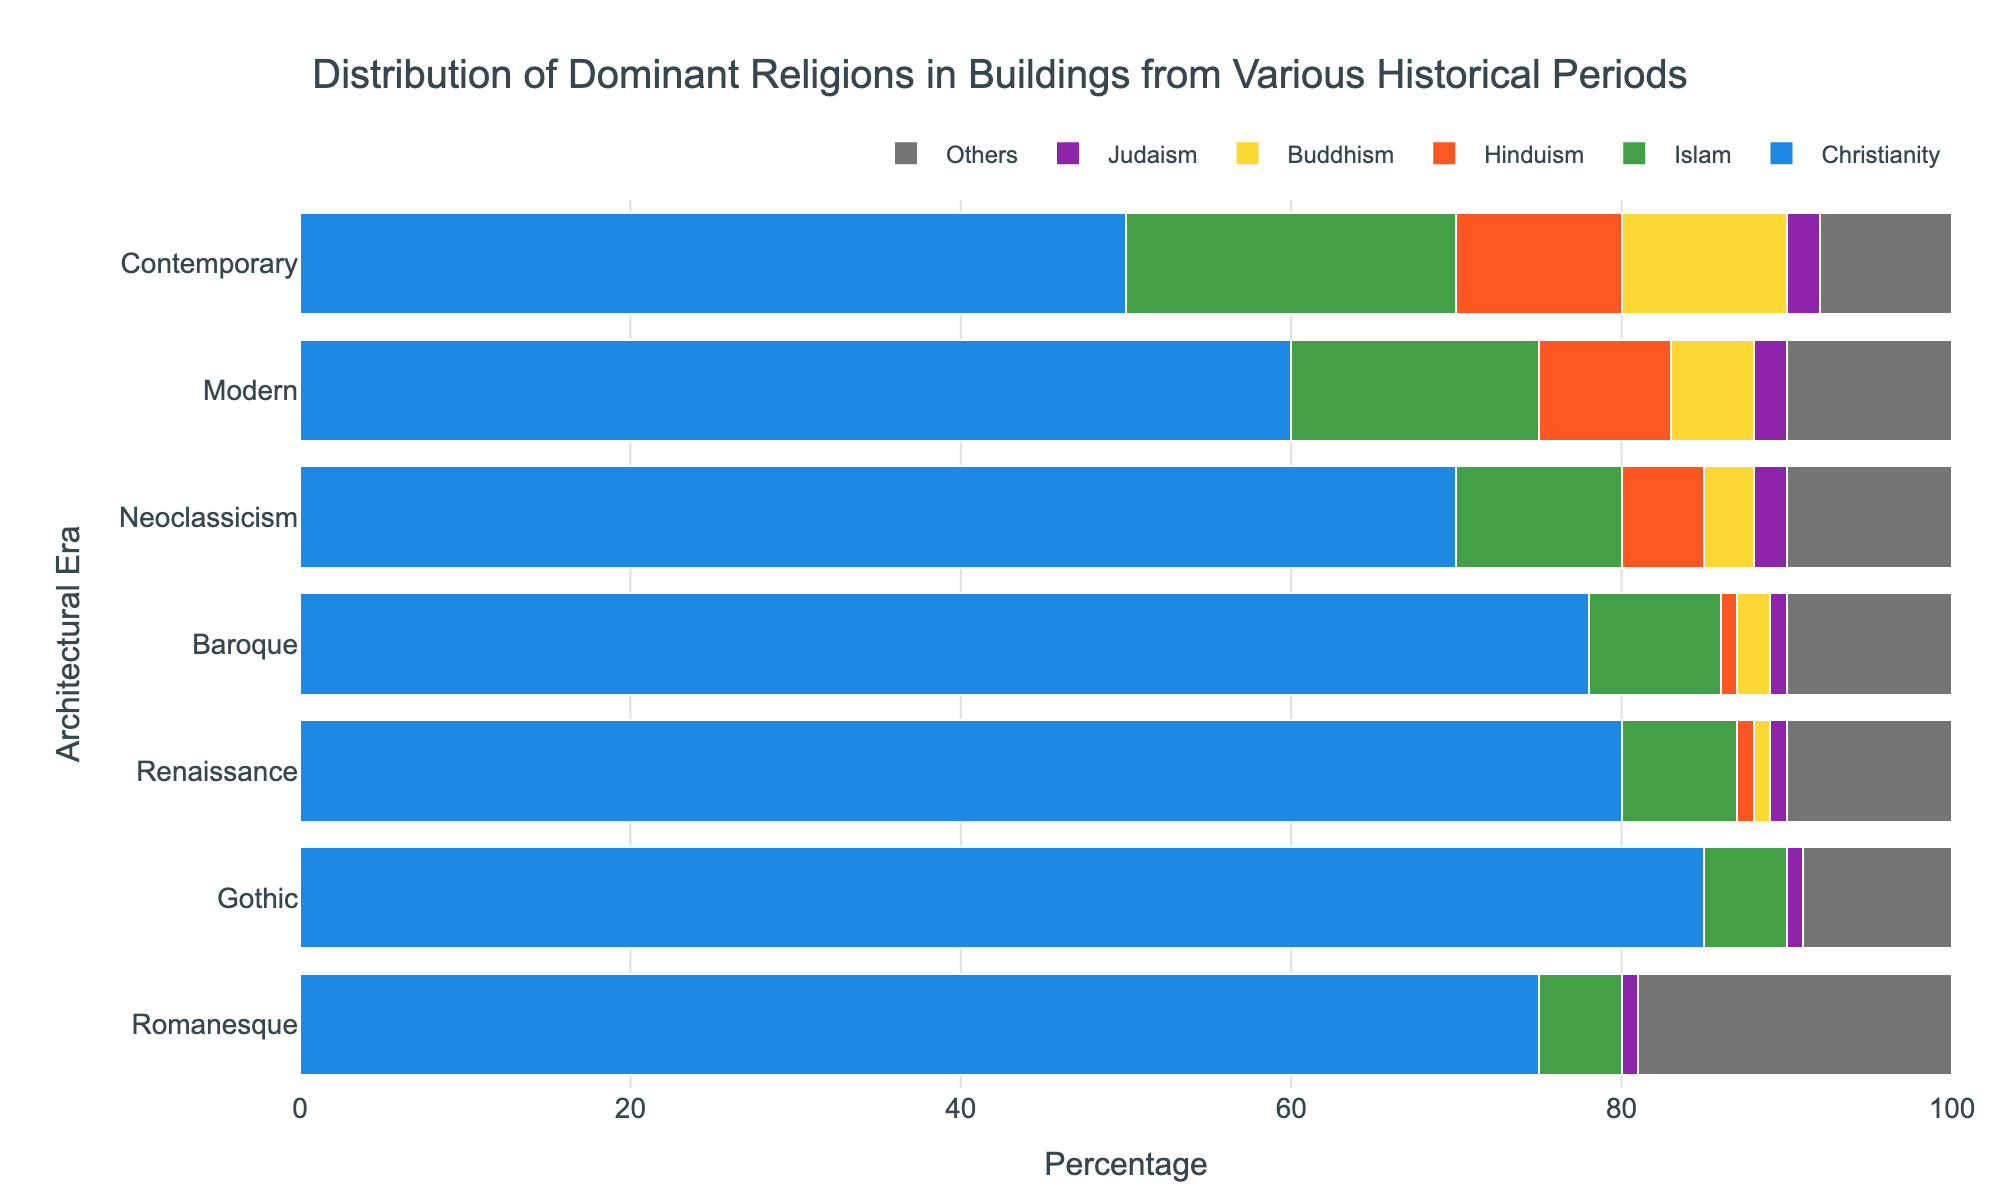What's the percentage of Christianity in the Romanesque era? Look at the Romanesque bar, find the segment representing Christianity, and note the percentage value.
Answer: 75 In which architectural era does Islam have the highest representation? Compare the percentages of Islam across all eras and identify the highest value.
Answer: Contemporary What is the total representation of Buddhism in the Renaissance and Baroque eras combined? Add the percentage values of Buddhism in both the Renaissance and Baroque bars. 1% (Renaissance) + 2% (Baroque) = 3%
Answer: 3% Which era shows the lowest percentage of 'Others'? Compare the 'Others' segment across all eras and identify the smallest value.
Answer: Gothic How does the presence of Judaism change from the Gothic to the Contemporary era? Track the percentage of Judaism from Gothic (1%) through each successive era up to Contemporary (2%).
Answer: It increases slightly Which two religions have the closest percentages in the Neoclassicism era? Compare the percentage values of all religions in Neoclassicism to see which two are closest.
Answer: Judaism and Others (both at 10%) What is the average percentage of Hinduism across all eras? Sum the percentages of Hinduism across all eras and divide by the number of eras. (0 + 0 + 1 + 1 + 5 + 8 + 10) / 7 = 3.57
Answer: 3.57 How does the representation of Islam in the Baroque era compare to its representation in the Gothic era? Look at the percentages of Islam in both the Gothic (5%) and Baroque (8%) eras, and compare them.
Answer: It is higher in the Baroque era What percentage of buildings in the Modern era belong to Christianity and others combined? Add the percentages of Christianity and Others in the Modern era. 60% (Christianity) + 10% (Others) = 70%
Answer: 70 Which era exhibits the most balanced distribution of religions (i.e., the least dominance by one religion)? Observe the bars and find the era where the percentages of different religions are the most evenly distributed.
Answer: Contemporary 